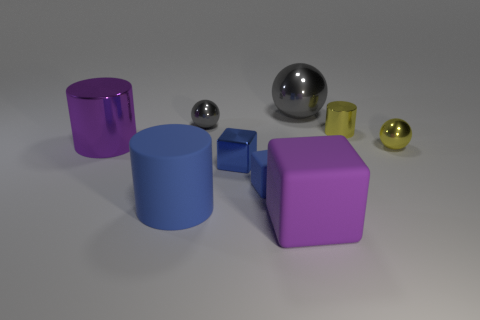Add 1 blue things. How many objects exist? 10 Add 5 purple objects. How many purple objects are left? 7 Add 7 purple shiny objects. How many purple shiny objects exist? 8 Subtract 0 cyan cylinders. How many objects are left? 9 Subtract all yellow spheres. Subtract all large red rubber spheres. How many objects are left? 8 